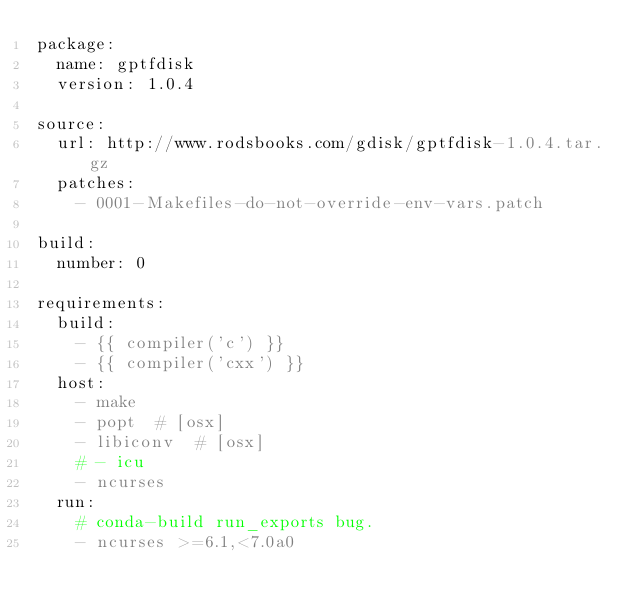Convert code to text. <code><loc_0><loc_0><loc_500><loc_500><_YAML_>package:
  name: gptfdisk
  version: 1.0.4

source:
  url: http://www.rodsbooks.com/gdisk/gptfdisk-1.0.4.tar.gz
  patches:
    - 0001-Makefiles-do-not-override-env-vars.patch

build:
  number: 0

requirements:
  build:
    - {{ compiler('c') }}
    - {{ compiler('cxx') }}
  host:
    - make
    - popt  # [osx]
    - libiconv  # [osx]
    # - icu
    - ncurses
  run:
    # conda-build run_exports bug.
    - ncurses >=6.1,<7.0a0
</code> 